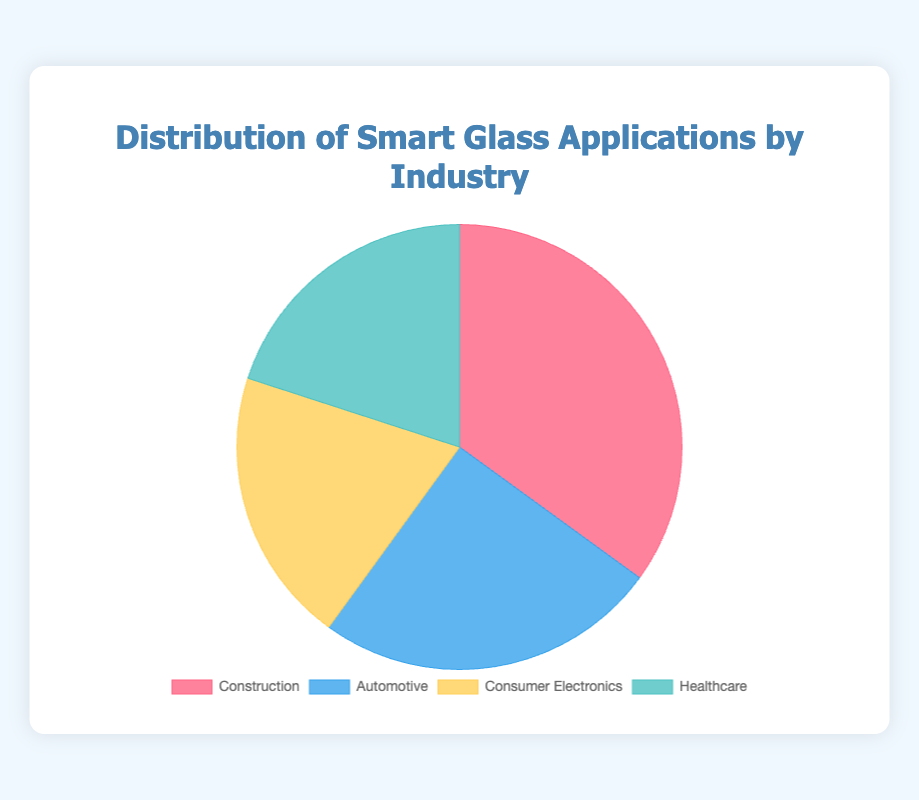What industry has the largest percentage of smart glass applications? The pie chart shows four industries, with Construction having the largest slice at 35%. Therefore, the Construction industry has the largest percentage of smart glass applications.
Answer: Construction Which two industries have an equal share of smart glass applications, and what is their percentage? By examining the pie chart, it is clear that Consumer Electronics and Healthcare both occupy equal slices of the pie, each with 20%.
Answer: Consumer Electronics and Healthcare, 20% How much greater is the percentage of smart glass applications in Construction compared to Automotive? Construction is represented with 35%, while Automotive is 25%. The difference is calculated as 35% - 25% = 10%. Thus, the Construction industry has 10% greater share than the Automotive industry.
Answer: 10% What is the combined percentage of smart glass applications in Consumer Electronics and Healthcare? Both Consumer Electronics and Healthcare have 20% each. Adding them together, we get 20% + 20% = 40%. Thus, the combined percentage for these two industries is 40%.
Answer: 40% Rank the industries from the highest to the lowest percentage of smart glass applications. The percentages shown on the pie chart are:
1. Construction: 35%
2. Automotive: 25%
3. Consumer Electronics: 20%
4. Healthcare: 20%
Thus, the ranking from highest to lowest is Construction, Automotive, Consumer Electronics, and Healthcare.
Answer: Construction, Automotive, Consumer Electronics, Healthcare What percentage of smart glass applications does the smallest category have? The pie chart indicates that the smallest categories are Consumer Electronics and Healthcare, each with 20%. Therefore, the smallest percentage is 20%.
Answer: 20% If you combine the percentages of Automotive and Healthcare, what is the result? The pie chart indicates that Automotive is 25%, and Healthcare is 20%. Adding these together, 25% + 20% = 45%. Thus, the combined percentage is 45%.
Answer: 45% What color represents the Healthcare industry in the pie chart? Observing the color codes in the pie chart, the Healthcare industry is represented by a shade of blue-green, lighter than green.
Answer: Blue-green Is the percentage of smart glass applications in Construction greater than the total percentage of smart glass applications in Consumer Electronics and Automotive? Construction has 35%. The combined percentage of Consumer Electronics and Automotive is 20% + 25% = 45%. Since 35% < 45%, Construction's percentage is not greater.
Answer: No 